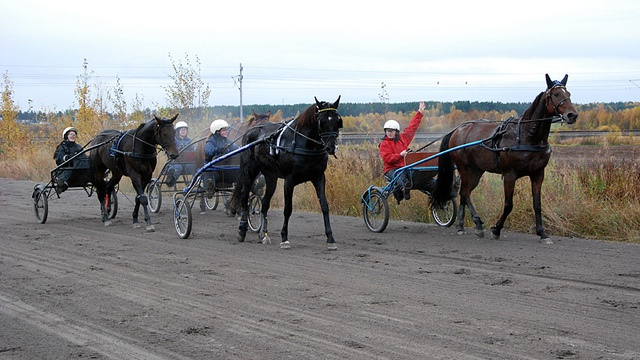Describe the objects in this image and their specific colors. I can see horse in white, black, gray, maroon, and navy tones, horse in white, black, and gray tones, horse in white, black, gray, and darkgray tones, people in white, black, brown, maroon, and gray tones, and people in white, black, and gray tones in this image. 